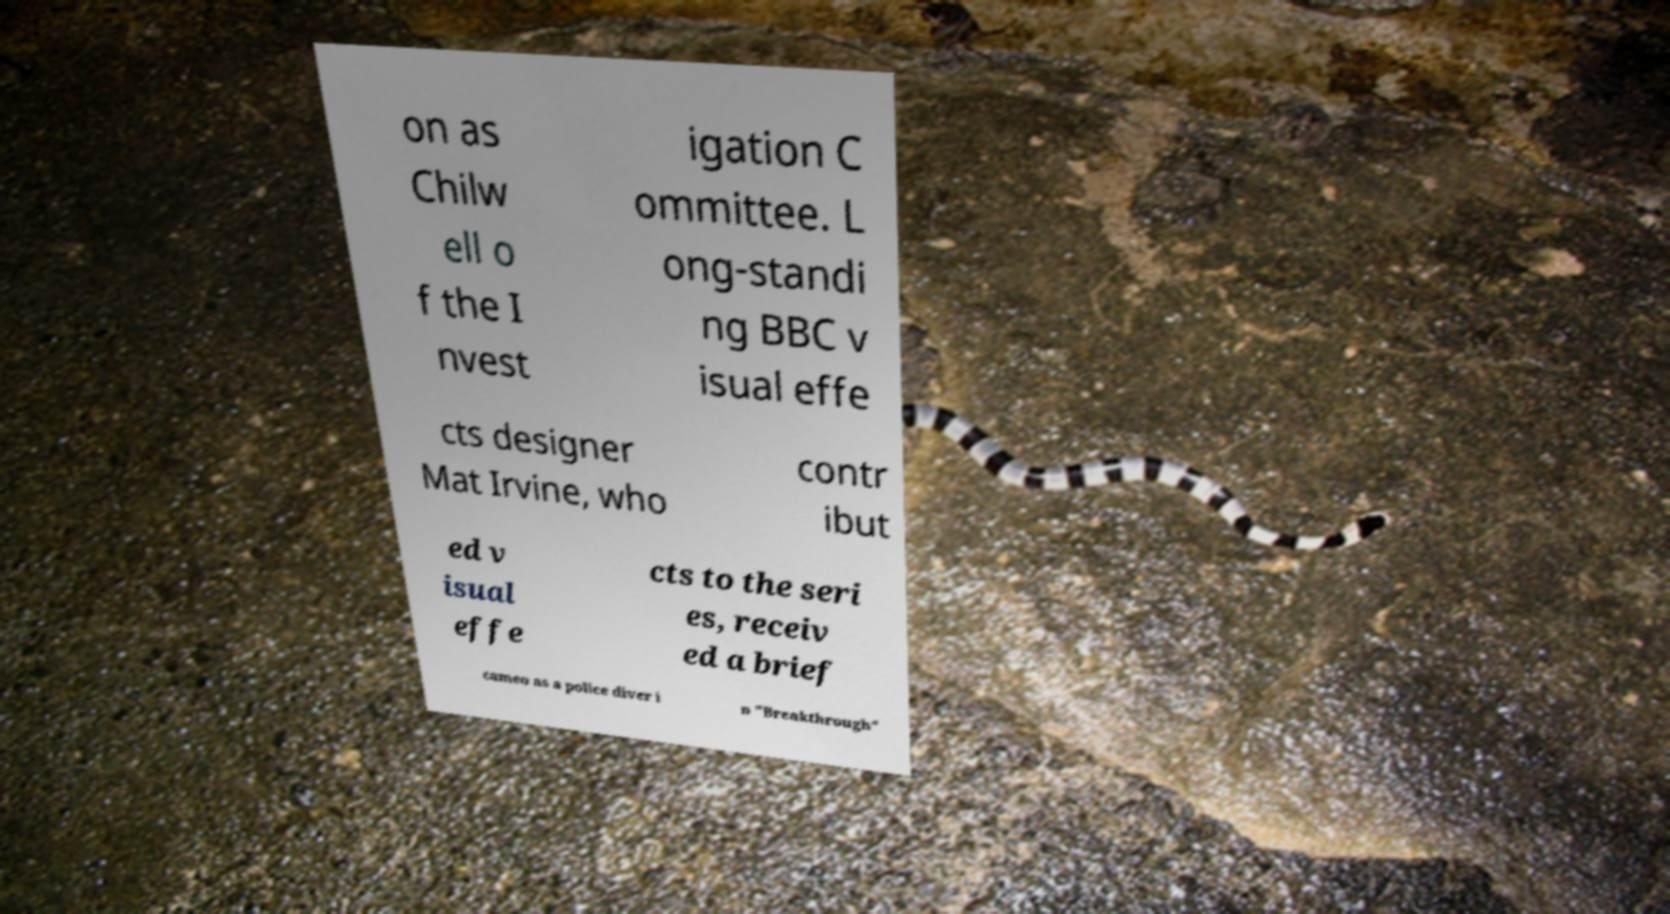Could you assist in decoding the text presented in this image and type it out clearly? on as Chilw ell o f the I nvest igation C ommittee. L ong-standi ng BBC v isual effe cts designer Mat Irvine, who contr ibut ed v isual effe cts to the seri es, receiv ed a brief cameo as a police diver i n "Breakthrough" 